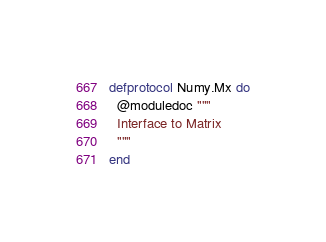<code> <loc_0><loc_0><loc_500><loc_500><_Elixir_>defprotocol Numy.Mx do
  @moduledoc """
  Interface to Matrix
  """
end
</code> 